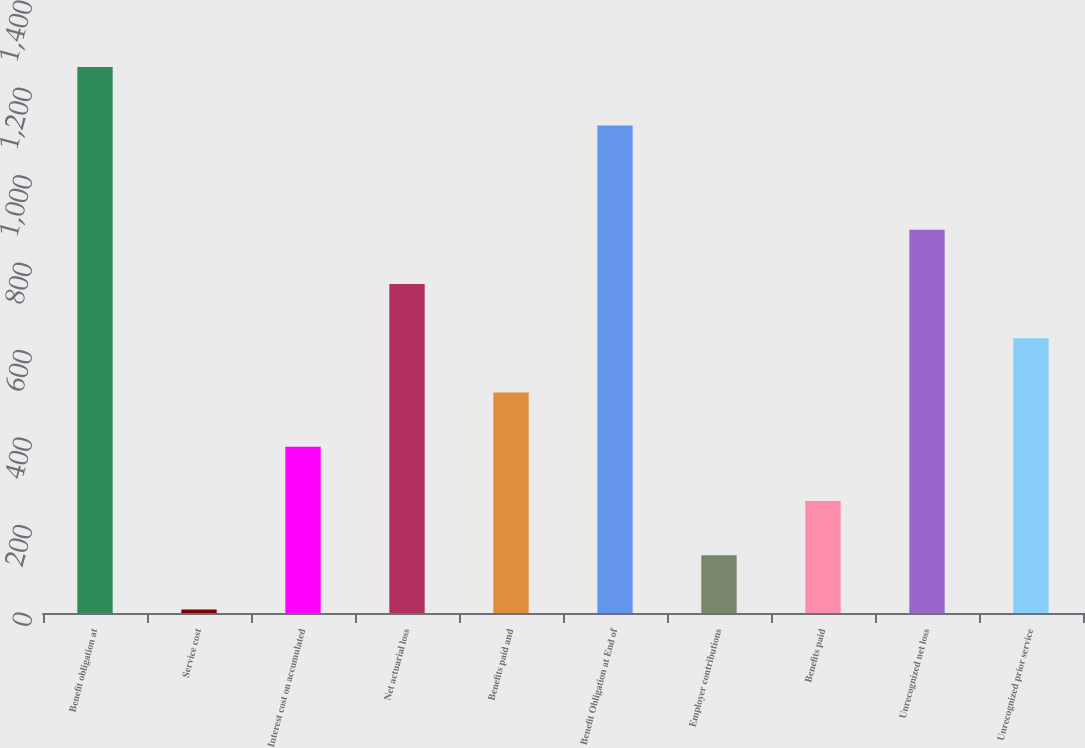Convert chart. <chart><loc_0><loc_0><loc_500><loc_500><bar_chart><fcel>Benefit obligation at<fcel>Service cost<fcel>Interest cost on accumulated<fcel>Net actuarial loss<fcel>Benefits paid and<fcel>Benefit Obligation at End of<fcel>Employer contributions<fcel>Benefits paid<fcel>Unrecognized net loss<fcel>Unrecognized prior service<nl><fcel>1249<fcel>8<fcel>380.3<fcel>752.6<fcel>504.4<fcel>1115<fcel>132.1<fcel>256.2<fcel>876.7<fcel>628.5<nl></chart> 